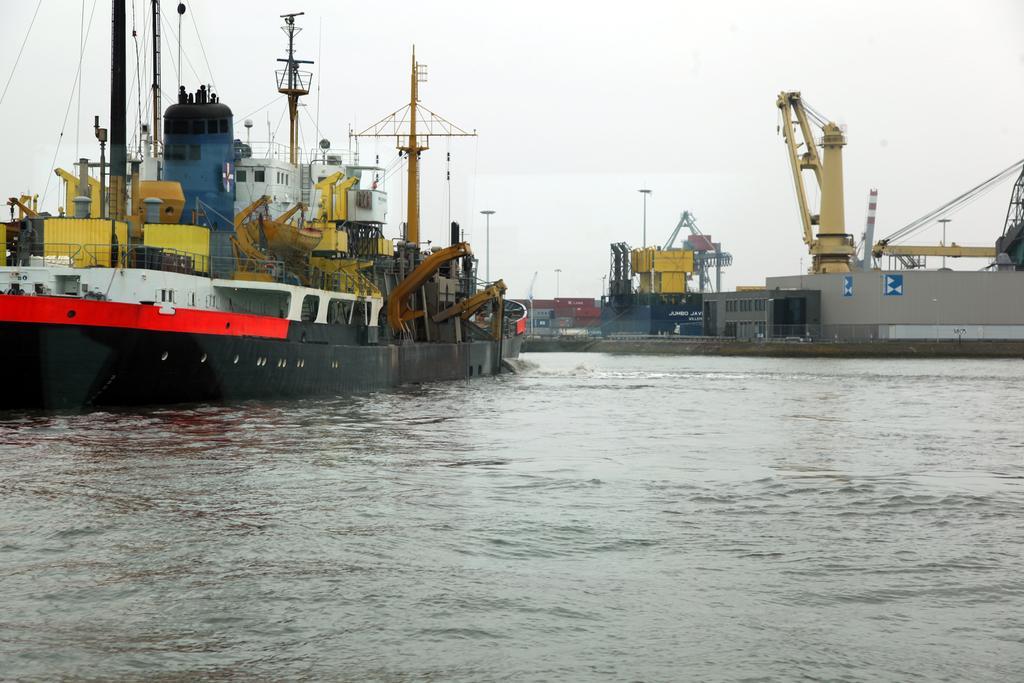Describe this image in one or two sentences. On the left there is a ship on the water and in it there are containers,ropes,poles and some other objects. In the background there are containers,heavy cranes,light poles,ropes,some other objects and sky. 